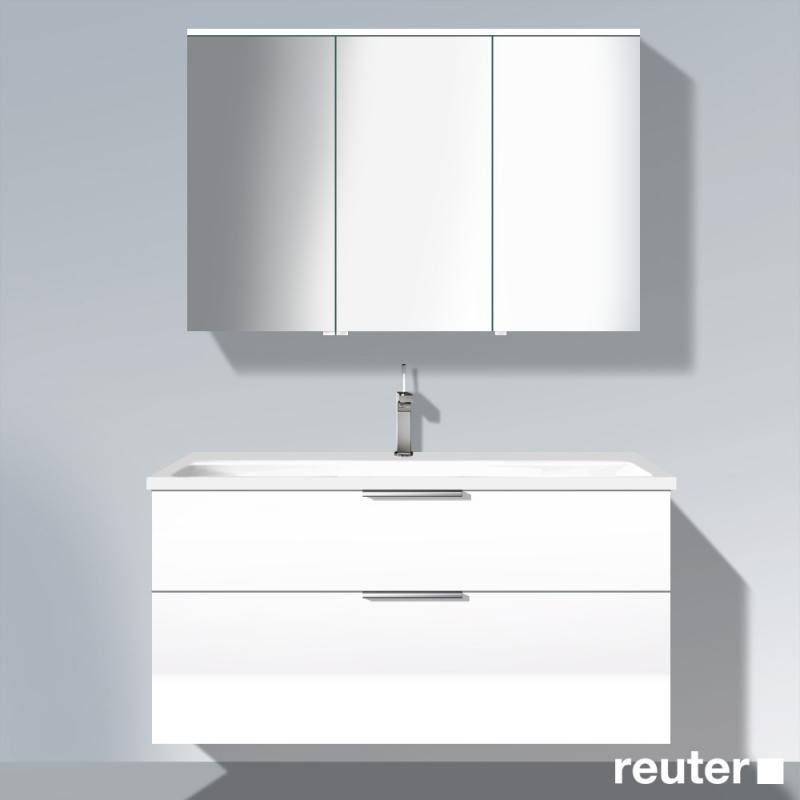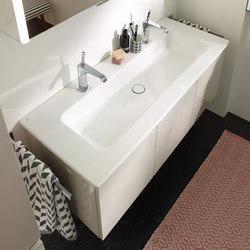The first image is the image on the left, the second image is the image on the right. Assess this claim about the two images: "In one image, a white vanity with white sink area has two chrome spout faucets and towels hanging on racks at each end of the vanity.". Correct or not? Answer yes or no. Yes. The first image is the image on the left, the second image is the image on the right. For the images displayed, is the sentence "The right image shows a top-view of a rectangular single-basin sink with a wall-mounted vanity that has a chrome towel bar on the side." factually correct? Answer yes or no. Yes. 